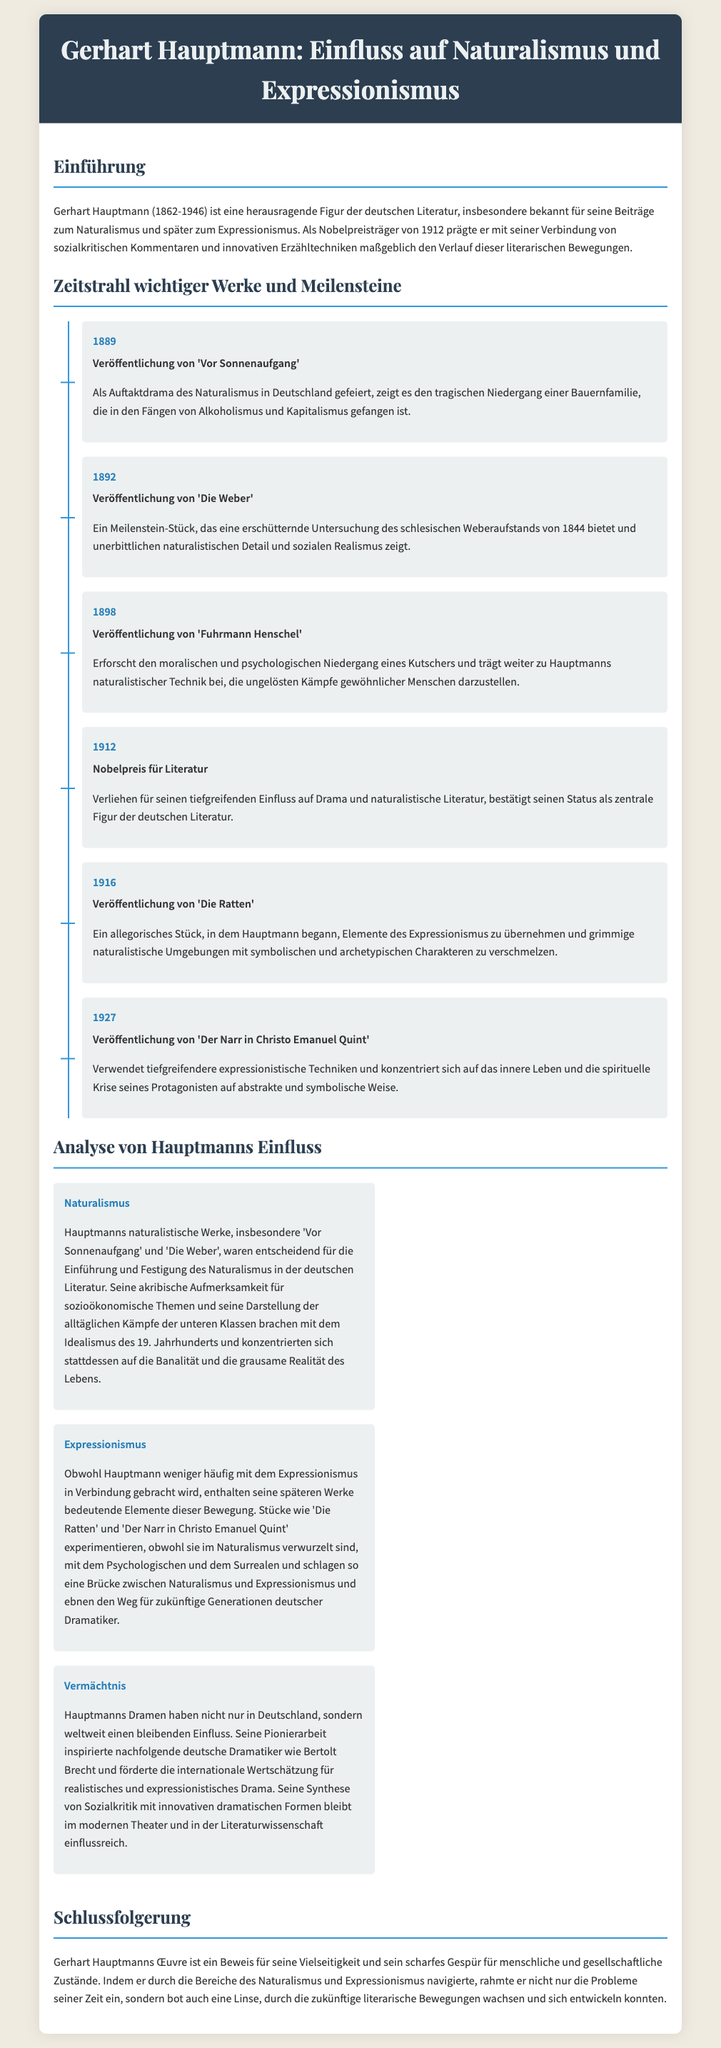What year was 'Vor Sonnenaufgang' published? The document states that 'Vor Sonnenaufgang' was published in 1889.
Answer: 1889 In which piece does Hauptmann explore the schlesian Weberaufstand? The document mentions that 'Die Weber' is a meilenstein-stück that explores the schlesian Weberaufstand of 1844.
Answer: Die Weber What significant award did Hauptmann receive in 1912? The document states that Hauptmann was awarded the Nobelpreis für Literatur in 1912.
Answer: Nobelpreis für Literatur Which work marks Hauptmann's incorporation of expressionistic elements? The document notes that 'Die Ratten' is where Hauptmann began incorporating elements of expressionism.
Answer: Die Ratten What aspect of literature did Hauptmann significantly influence? The document indicates that Hauptmann's work influenced dramatic literature through his social critiques.
Answer: Dramatic literature What is the major theme in Hauptmann's naturalistic works? The document describes Hauptmann's attention to socio-economic themes and the struggles of lower classes in his naturalistic works.
Answer: Socio-economic themes Which movements did Hauptmann's works bridge? The document states that Hauptmann's later works bridged Naturalismus and Expressionismus.
Answer: Naturalismus and Expressionismus What is a key feature of Hauptmann's legacy according to the document? The document emphasizes Hauptmann's pioneering work that inspired subsequent German dramatists as a key feature of his legacy.
Answer: Inspiring subsequent German dramatists 